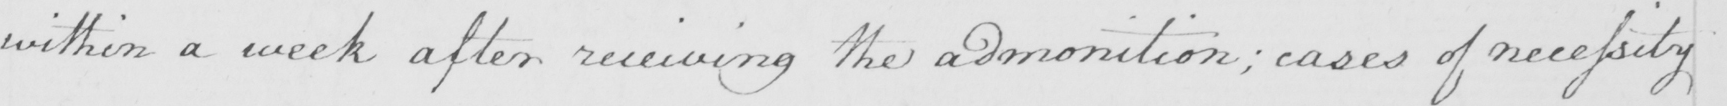What does this handwritten line say? within a week after receiving the admonition  ; cases of necessity 